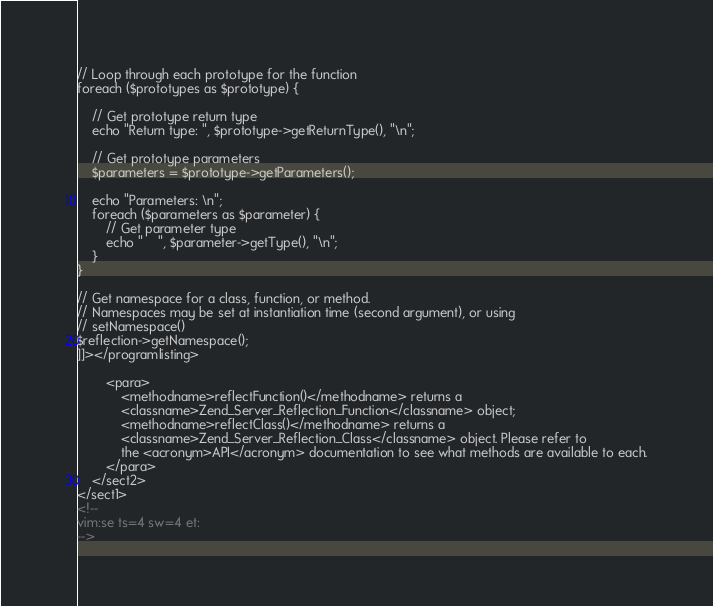<code> <loc_0><loc_0><loc_500><loc_500><_XML_>// Loop through each prototype for the function
foreach ($prototypes as $prototype) {

    // Get prototype return type
    echo "Return type: ", $prototype->getReturnType(), "\n";

    // Get prototype parameters
    $parameters = $prototype->getParameters();

    echo "Parameters: \n";
    foreach ($parameters as $parameter) {
        // Get parameter type
        echo "    ", $parameter->getType(), "\n";
    }
}

// Get namespace for a class, function, or method.
// Namespaces may be set at instantiation time (second argument), or using
// setNamespace()
$reflection->getNamespace();
]]></programlisting>

        <para>
            <methodname>reflectFunction()</methodname> returns a
            <classname>Zend_Server_Reflection_Function</classname> object;
            <methodname>reflectClass()</methodname> returns a
            <classname>Zend_Server_Reflection_Class</classname> object. Please refer to
            the <acronym>API</acronym> documentation to see what methods are available to each.
        </para>
    </sect2>
</sect1>
<!--
vim:se ts=4 sw=4 et:
-->
</code> 